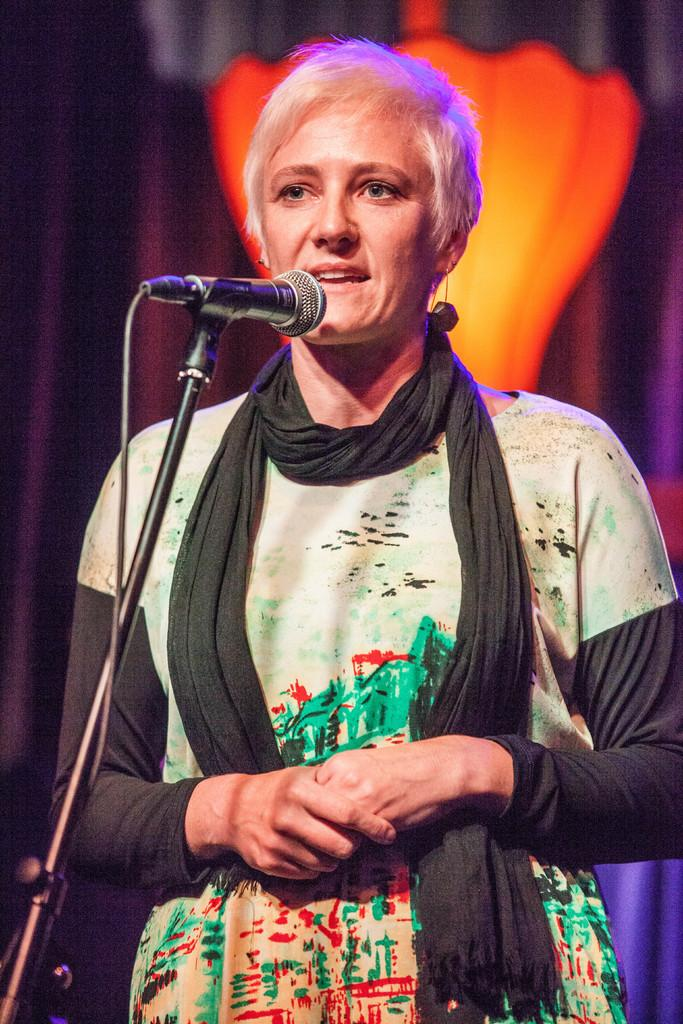Who is the main subject in the image? There is a woman in the image. What is the woman doing in the image? The woman is standing in front of a mic. What is the woman wearing around her neck? The woman is wearing a black stole around her neck. How is the background of the woman depicted in the image? The background of the woman is blurred. How many visitors can be seen in the image? There are no visitors present in the image; it only features a woman standing in front of a mic. What type of paper is the woman holding in the image? There is no paper visible in the image; the woman is standing in front of a mic without any visible paper. 